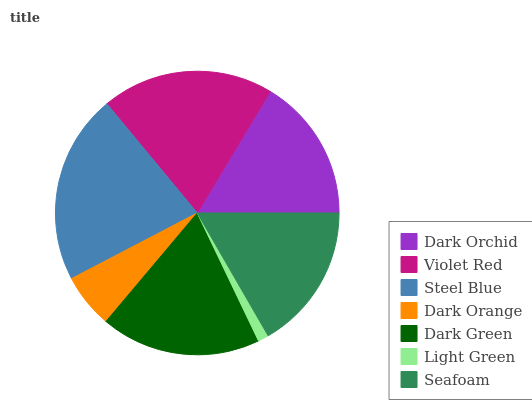Is Light Green the minimum?
Answer yes or no. Yes. Is Steel Blue the maximum?
Answer yes or no. Yes. Is Violet Red the minimum?
Answer yes or no. No. Is Violet Red the maximum?
Answer yes or no. No. Is Violet Red greater than Dark Orchid?
Answer yes or no. Yes. Is Dark Orchid less than Violet Red?
Answer yes or no. Yes. Is Dark Orchid greater than Violet Red?
Answer yes or no. No. Is Violet Red less than Dark Orchid?
Answer yes or no. No. Is Seafoam the high median?
Answer yes or no. Yes. Is Seafoam the low median?
Answer yes or no. Yes. Is Light Green the high median?
Answer yes or no. No. Is Dark Orange the low median?
Answer yes or no. No. 